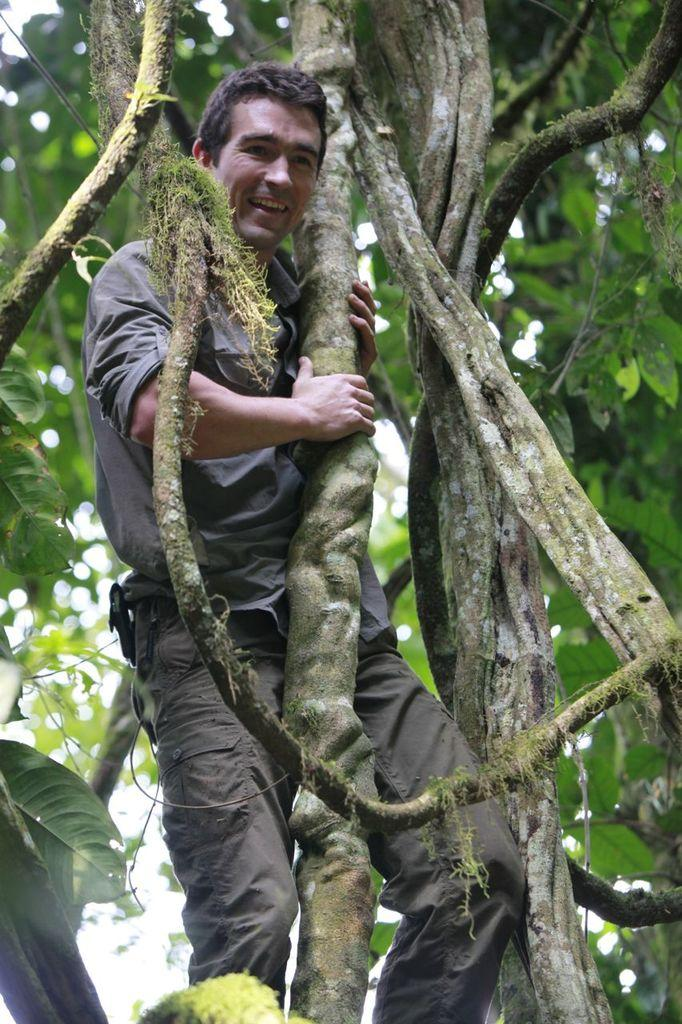What is the main subject of the image? There is a person in the image. What is the person doing in the image? The person is standing in the image. What object is the person holding in the image? The person is holding a branch of a tree in the image. What is the person's belief about the amount of lift they can achieve with the branch? There is no information about the person's beliefs or the amount of lift in the image, as it only shows a person standing and holding a branch of a tree. 